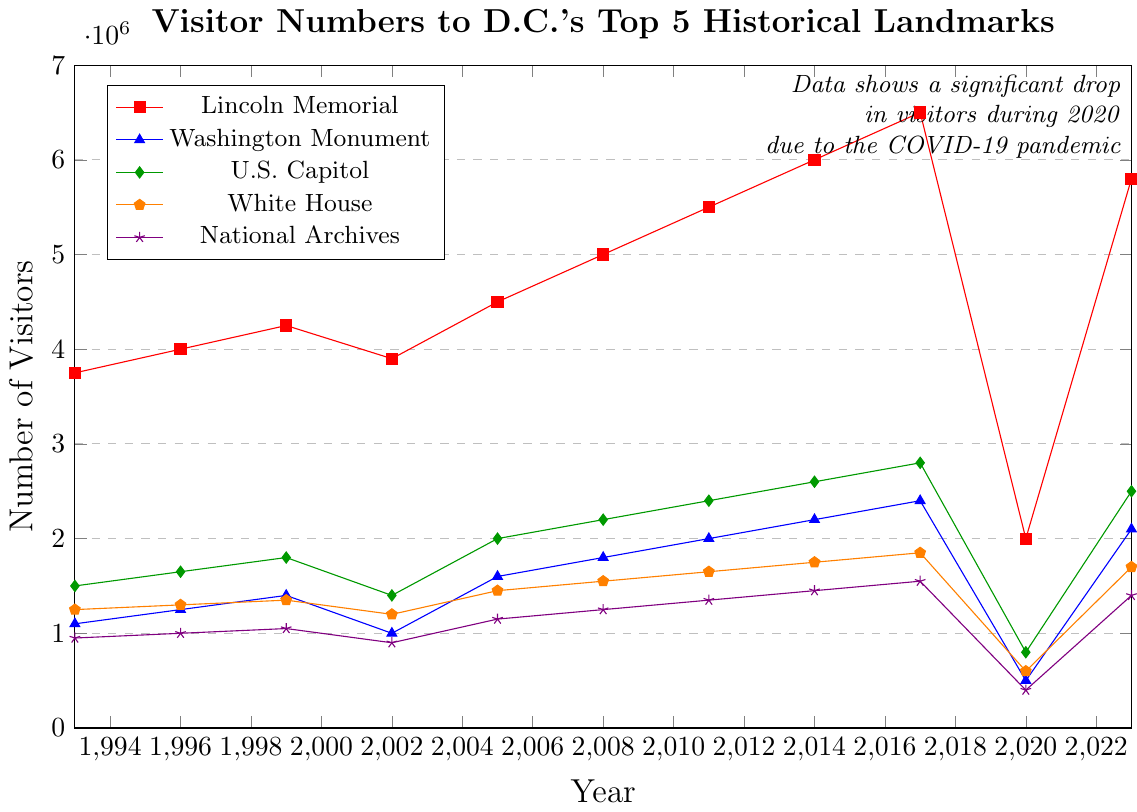What is the highest number of visitors recorded for a single landmark between 1993 and 2023? The highest line on the plot represents the highest number of visitors. The Lincoln Memorial reaches 6,500,000 visitors in 2017, which is the peak for a single landmark in the time period.
Answer: 6,500,000 How did the visitor numbers for the Washington Monument change from 2023 compared to its lowest point in 2020? In 2020, the Washington Monument had about 500,000 visitors, and in 2023, it had 2,100,000 visitors. The increase is calculated as 2,100,000 - 500,000.
Answer: 1,600,000 Which landmark experienced the most significant drop in visitor numbers during 2020? By looking at the plot, all landmarks experienced a drop in 2020, but the Lincoln Memorial shows the most significant drop from 6,500,000 in 2017 to 2,000,000 in 2020, a decrease of 4,500,000.
Answer: The Lincoln Memorial Identify the trend in visitor numbers to the National Archives between 1993 and 2023. The National Archives showed a generally increasing trend in visitor numbers from 1993 (950,000) to 2023 (1,400,000), with a peak in 2017 (1,550,000) and a notable drop in 2020 (400,000) due to the pandemic.
Answer: Generally increasing with a drop in 2020 What was the combined visitor number for the Lincoln Memorial and the Washington Monument in 2011? In 2011, the Lincoln Memorial had 5,500,000 visitors, and the Washington Monument had 2,000,000 visitors. The combined number is the sum of these two figures: 5,500,000 + 2,000,000.
Answer: 7,500,000 Which landmark had the most consistent increase in visitors from 1993 to 2017? Looking at the trend lines, the Lincoln Memorial shows a consistent increase from 1993 (3,750,000) to 2017 (6,500,000). Other landmarks had more fluctuations.
Answer: The Lincoln Memorial In which year did the White House visitor numbers peak, and what was the number? By examining the plot, the highest point for the White House visitor numbers is in 2017, with 1,850,000 visitors.
Answer: 2017, 1,850,000 How does the number of visitors to the U.S. Capitol in 2023 compare to its numbers in 2008? Refer to the plot: In 2008, the U.S. Capitol had 2,200,000 visitors, and in 2023, it had 2,500,000 visitors. The comparison shows an increase of 300,000.
Answer: 2,500,000 What is the average number of visitors to the White House over three selected years: 1993, 2005, and 2017? The number of visitors for those years are 1,250,000 (1993), 1,450,000 (2005), and 1,850,000 (2017). Calculate the average: (1,250,000 + 1,450,000 + 1,850,000) / 3.
Answer: 1,516,667 